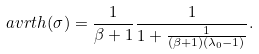<formula> <loc_0><loc_0><loc_500><loc_500>\ a v r t h ( \sigma ) = \frac { 1 } { \beta + 1 } \frac { 1 } { 1 + \frac { 1 } { ( \beta + 1 ) ( \lambda _ { 0 } - 1 ) } } .</formula> 